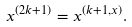Convert formula to latex. <formula><loc_0><loc_0><loc_500><loc_500>x ^ { ( 2 k + 1 ) } = x ^ { ( k + 1 , x ) } .</formula> 